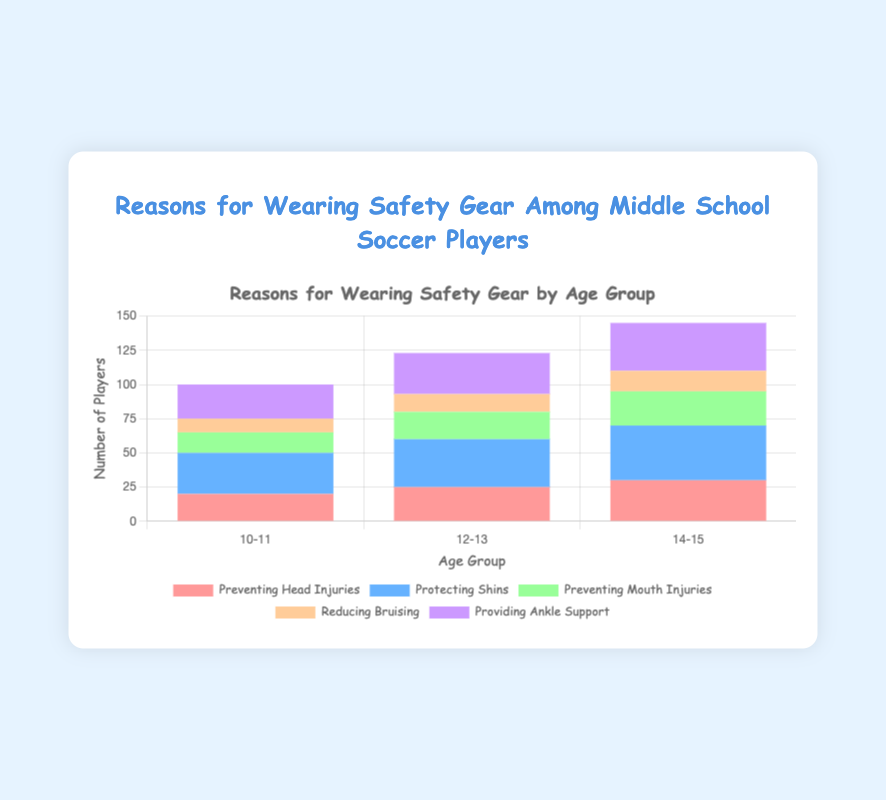Which age group has the highest number of players concerned with protecting their shins? Look for the age group with the tallest bar section corresponding to "Protecting Shins" which is represented by the blue color. The 14-15 age group has the highest value at 40 players.
Answer: 14-15 Which reason for wearing safety gear has the lowest number of players in the 10-11 age group? Check each segment of the bar for the 10-11 age group and identify the smallest section. The smallest section is "Reducing Bruising" with 10 players.
Answer: Reducing Bruising What's the total number of players in the 12-13 age group that are concerned with both preventing head injuries and preventing mouth injuries? Add the values for "Preventing Head Injuries" (25) and "Preventing Mouth Injuries" (20) for the 12-13 age group. 25 + 20 = 45.
Answer: 45 How does the number of players who value providing ankle support compare between the 10-11 and 14-15 age groups? Compare the values of "Providing Ankle Support" for both age groups. The 10-11 group has 25 players while the 14-15 group has 35 players. 35 > 25.
Answer: 35 > 25 Which reason has consistently the highest number of players across all age groups? Identify the reason with the highest segment in each age group's stacked bar. "Protecting Shins" consistently has the highest numbers of 30, 35, and 40.
Answer: Protecting Shins What's the sum of all players concerned with preventing mouth injuries across all age groups? Add the "Preventing Mouth Injuries" values for all age groups: 15 (10-11) + 20 (12-13) + 25 (14-15). 15 + 20 + 25 = 60.
Answer: 60 In the 14-15 age group, how much larger is the number of players concerned with protecting shins than reducing bruising? Subtract the "Reducing Bruising" value from the "Protecting Shins" value in the 14-15 age group: 40 - 15 = 25.
Answer: 25 For the 12-13 age group, what percentage of players are concerned with providing ankle support out of those recording any concern at all? First calculate the total number of players for the 12-13 age group by summing all reasons: 25 + 35 + 20 + 13 + 30 = 123. Then find the percentage for "Providing Ankle Support": (30 / 123) * 100 ≈ 24.39%.
Answer: 24.39% What's the difference between the number of players concerned with preventing head injuries in the 10-11 age group and the 14-15 age group? Subtract the number of players for "Preventing Head Injuries" in the 10-11 age group from those in the 14-15 age group: 30 - 20 = 10.
Answer: 10 Which reason for wearing safety gear in the 14-15 age group shows an equal number of players as "Preventing Head Injuries" in the 12-13 age group? Match the value for "Preventing Head Injuries" in the 12-13 age group (25) with another reason in the 14-15 group. "Preventing Mouth Injuries" in the 14-15 group is also 25.
Answer: Preventing Mouth Injuries 